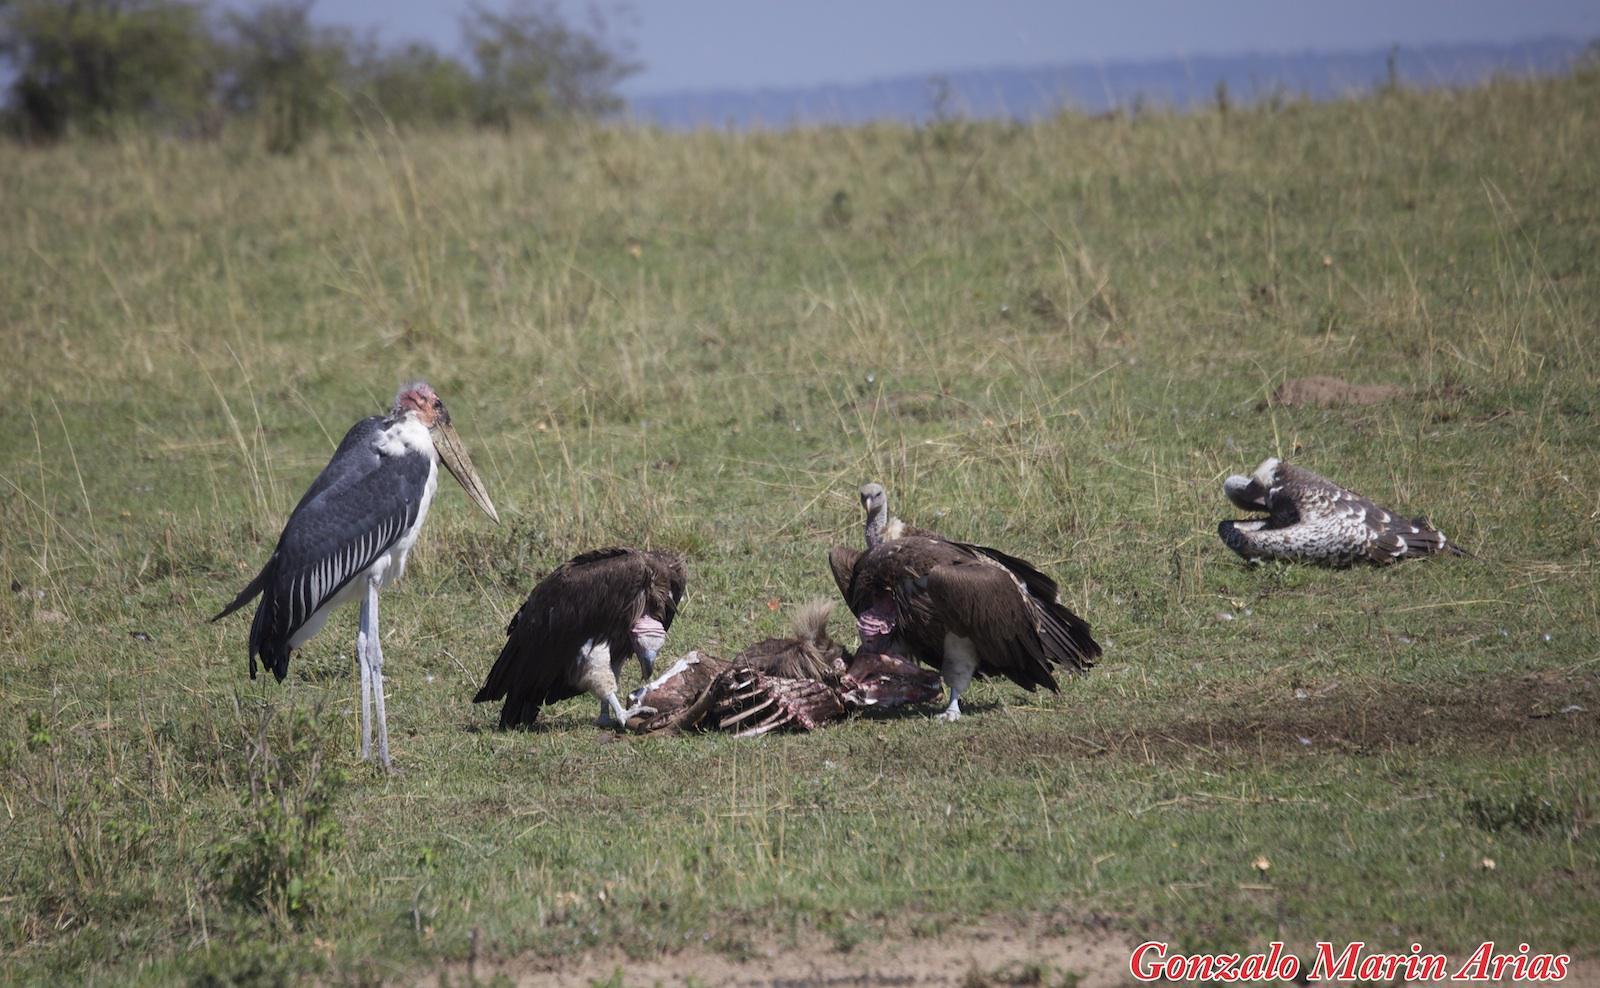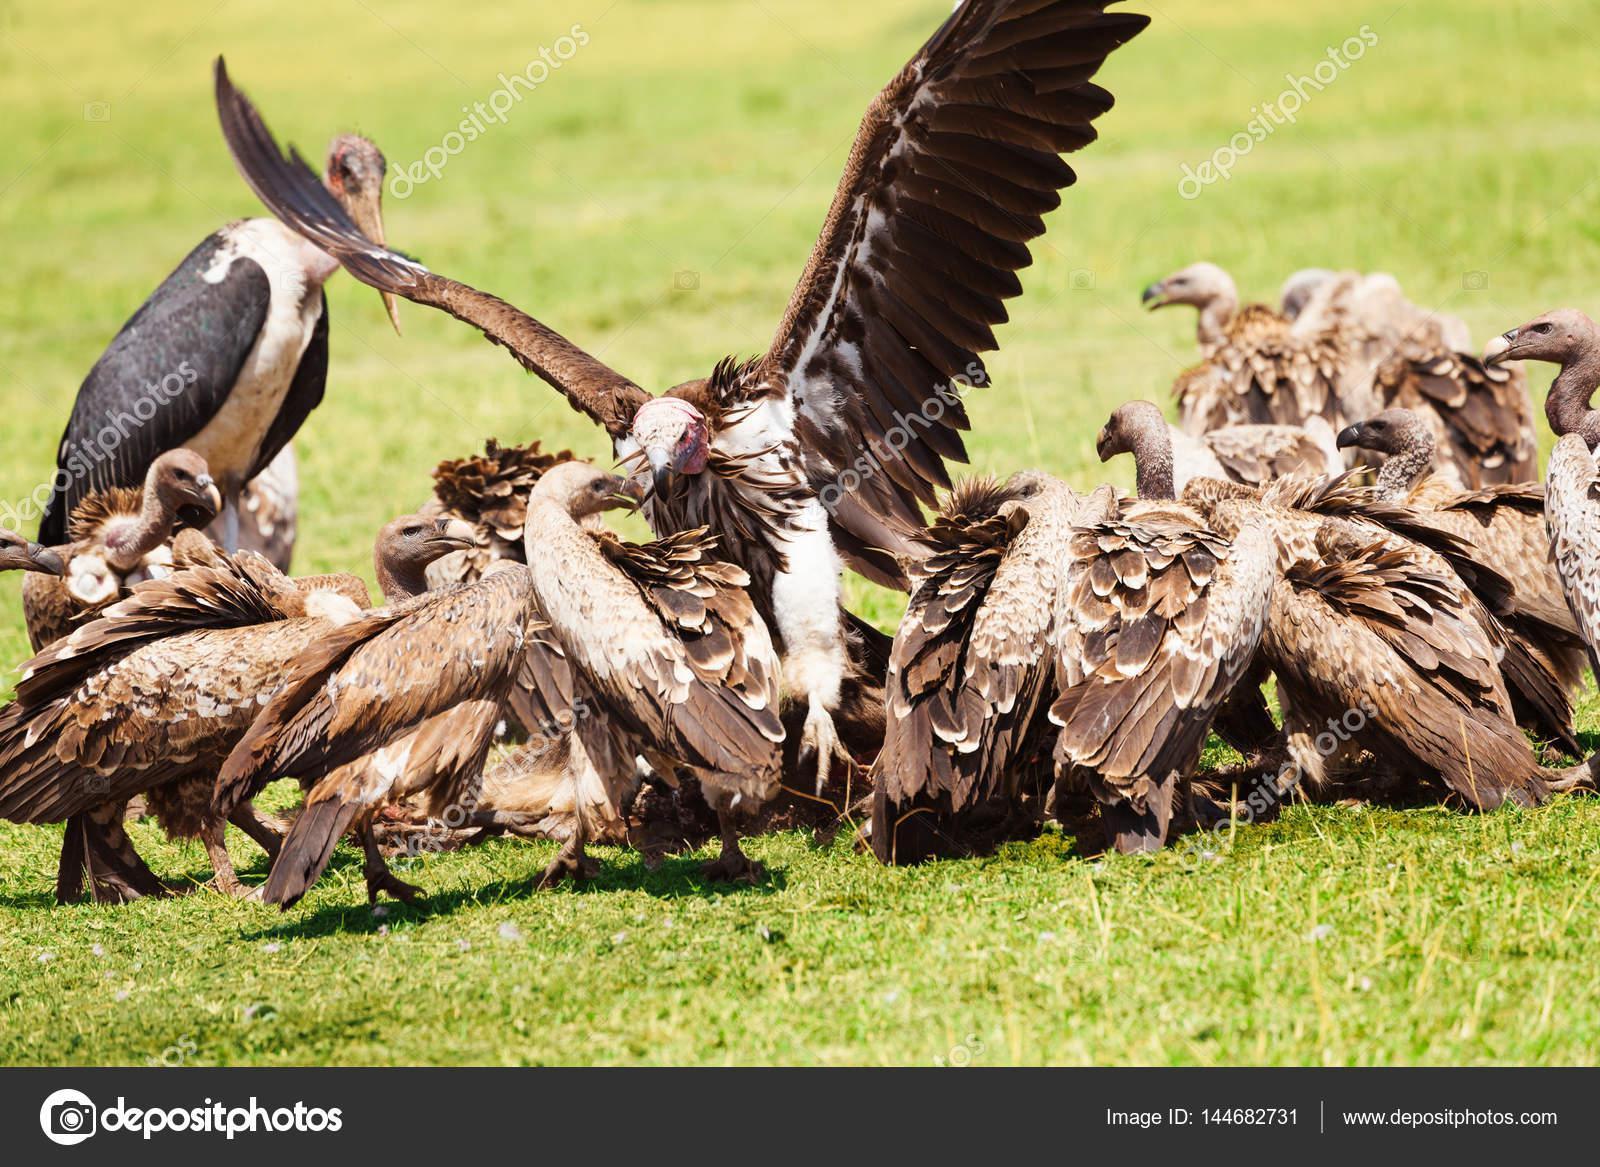The first image is the image on the left, the second image is the image on the right. Given the left and right images, does the statement "None of the birds have outstretched wings in the image on the left." hold true? Answer yes or no. Yes. 